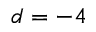Convert formula to latex. <formula><loc_0><loc_0><loc_500><loc_500>d = - 4</formula> 